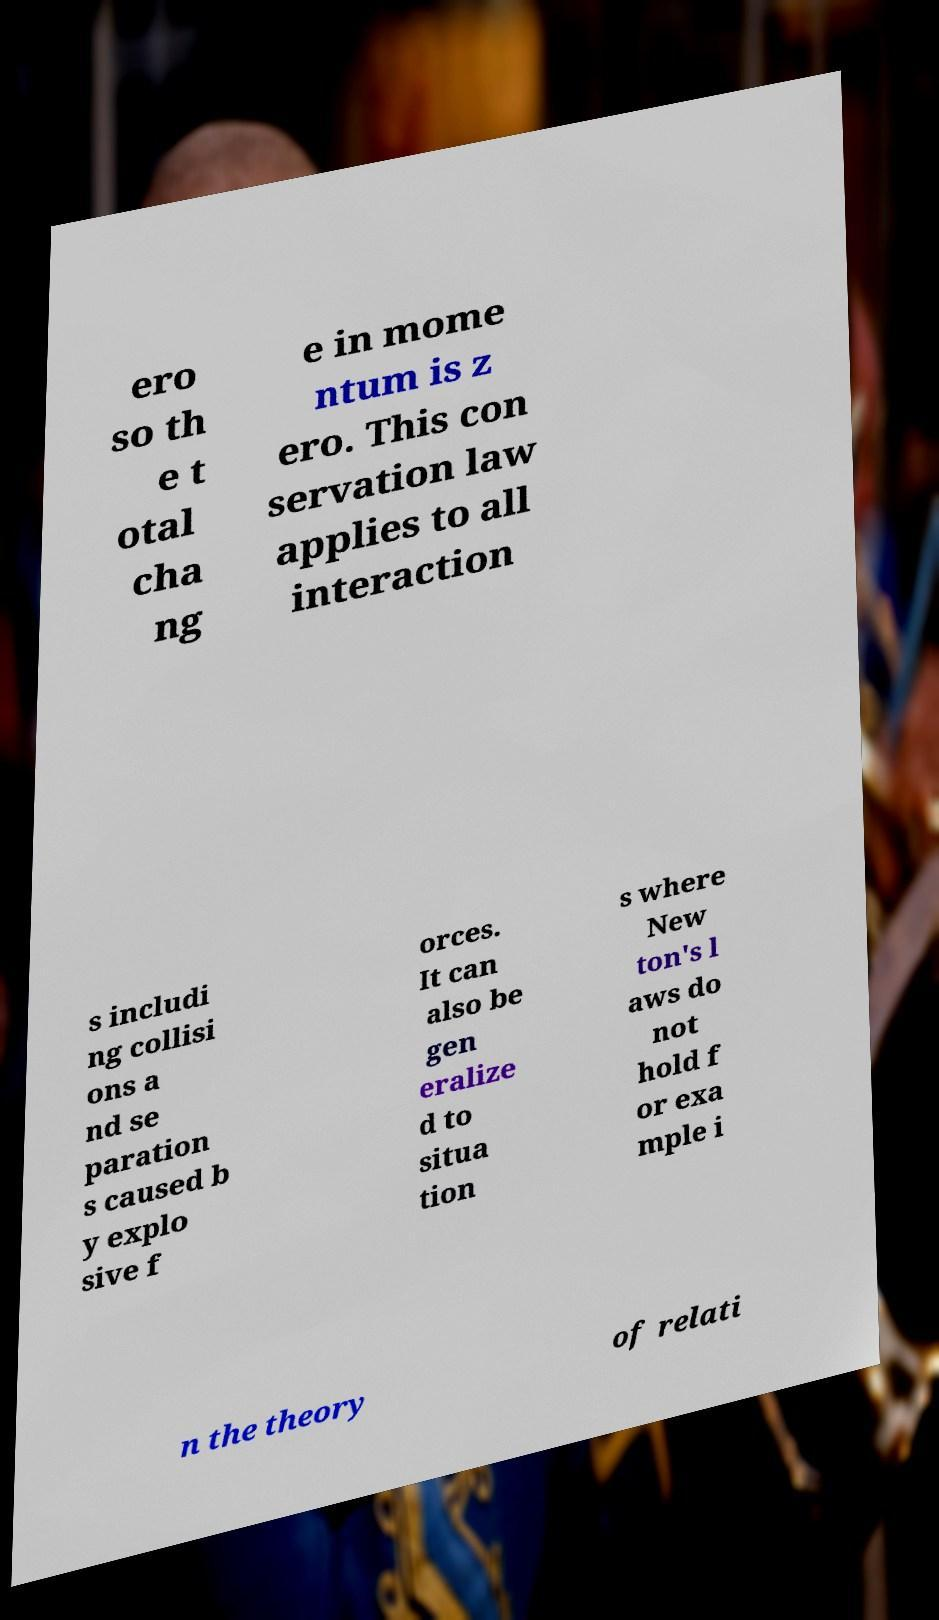There's text embedded in this image that I need extracted. Can you transcribe it verbatim? ero so th e t otal cha ng e in mome ntum is z ero. This con servation law applies to all interaction s includi ng collisi ons a nd se paration s caused b y explo sive f orces. It can also be gen eralize d to situa tion s where New ton's l aws do not hold f or exa mple i n the theory of relati 